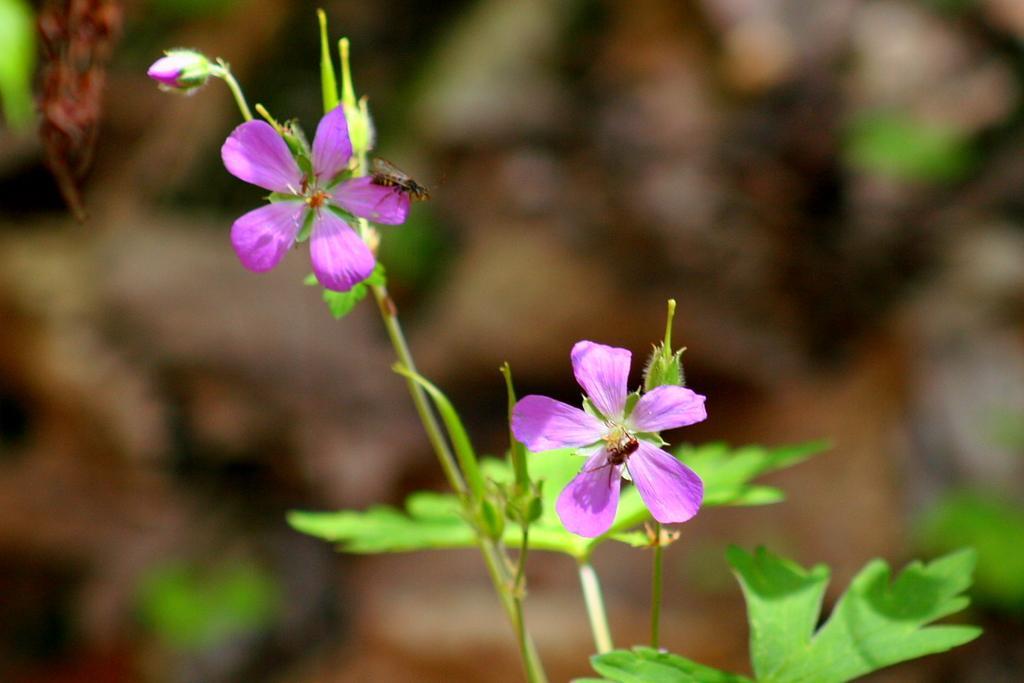Could you give a brief overview of what you see in this image? The picture consists of flowers, leaves, stems and insects. The background is blurred. 